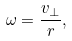Convert formula to latex. <formula><loc_0><loc_0><loc_500><loc_500>\omega = { \frac { v _ { \perp } } { r } } ,</formula> 